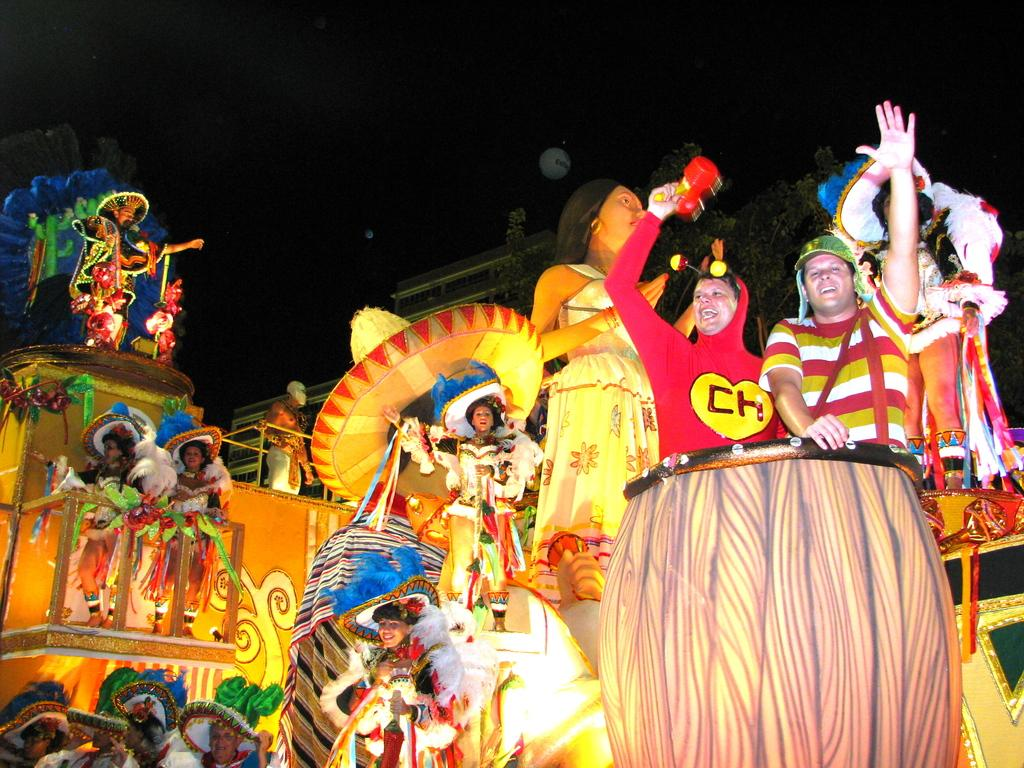Who can be seen in the image? There are people in the image. What are the people doing in the image? The people are performing. What event is the performance part of? The performance is part of a carnival parade. What are the people wearing during the performance? The people are wearing costumes. What type of loaf is being carried by the fowl in the image? There is no fowl or loaf present in the image. How does the society depicted in the image contribute to the performance? The image does not depict a society, only a group of people performing in a carnival parade. 